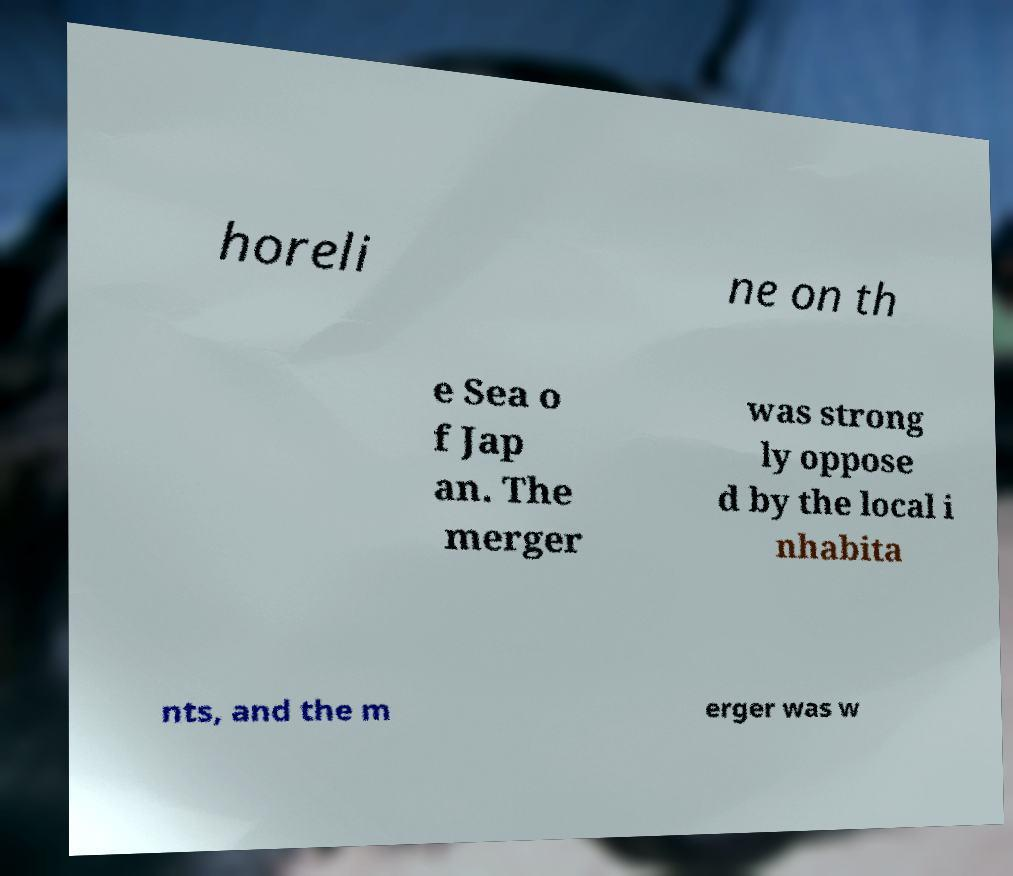Can you accurately transcribe the text from the provided image for me? horeli ne on th e Sea o f Jap an. The merger was strong ly oppose d by the local i nhabita nts, and the m erger was w 